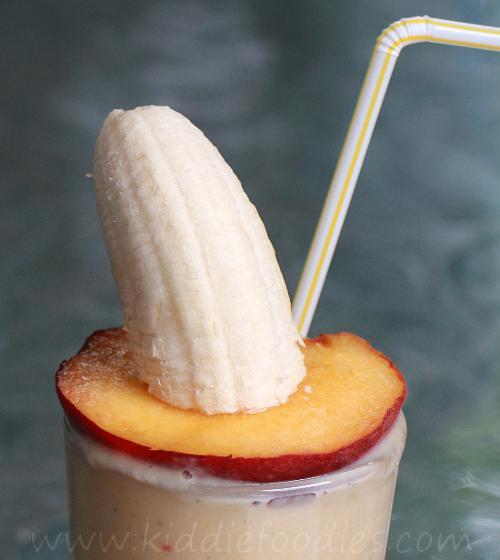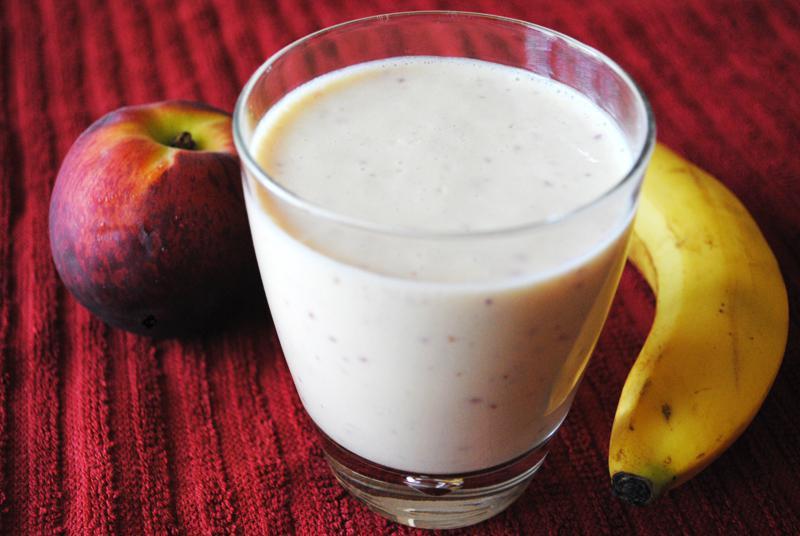The first image is the image on the left, the second image is the image on the right. Considering the images on both sides, is "There is a full white cup with one whole banana and apple on either side of it." valid? Answer yes or no. Yes. The first image is the image on the left, the second image is the image on the right. Assess this claim about the two images: "There is whole uncut fruit in the right image.". Correct or not? Answer yes or no. Yes. 